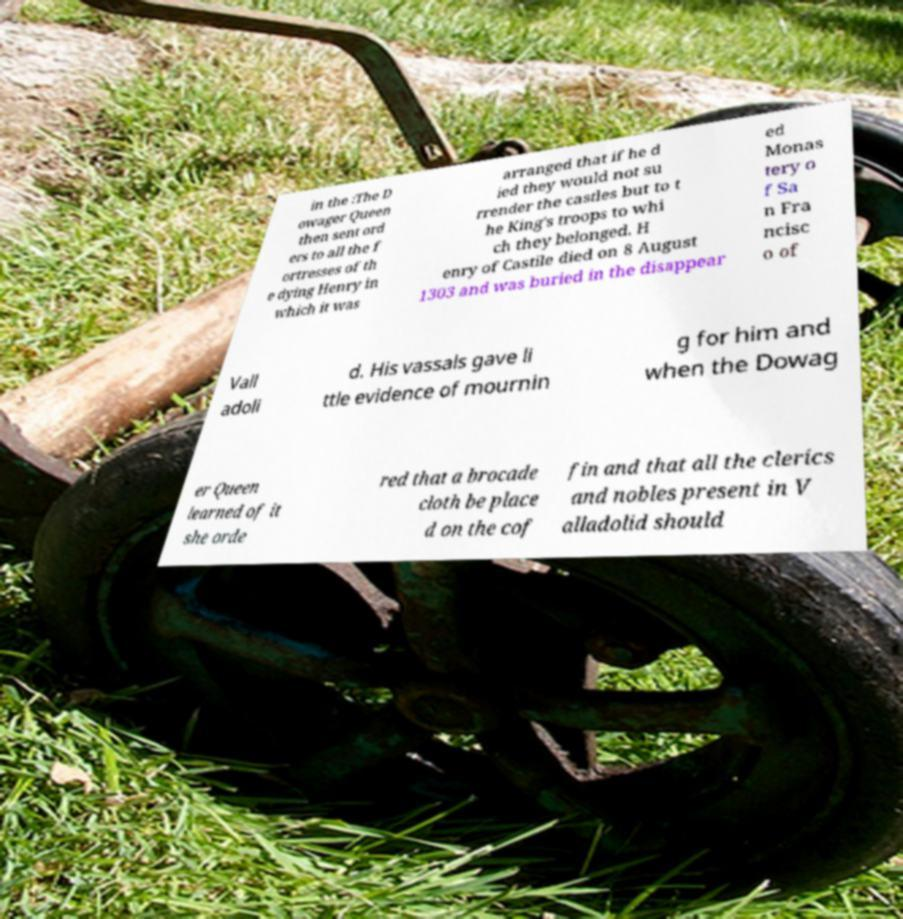Could you assist in decoding the text presented in this image and type it out clearly? in the :The D owager Queen then sent ord ers to all the f ortresses of th e dying Henry in which it was arranged that if he d ied they would not su rrender the castles but to t he King's troops to whi ch they belonged. H enry of Castile died on 8 August 1303 and was buried in the disappear ed Monas tery o f Sa n Fra ncisc o of Vall adoli d. His vassals gave li ttle evidence of mournin g for him and when the Dowag er Queen learned of it she orde red that a brocade cloth be place d on the cof fin and that all the clerics and nobles present in V alladolid should 